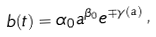Convert formula to latex. <formula><loc_0><loc_0><loc_500><loc_500>b ( t ) = \alpha _ { 0 } a ^ { \beta _ { 0 } } e ^ { \mp \gamma ( a ) } \, ,</formula> 